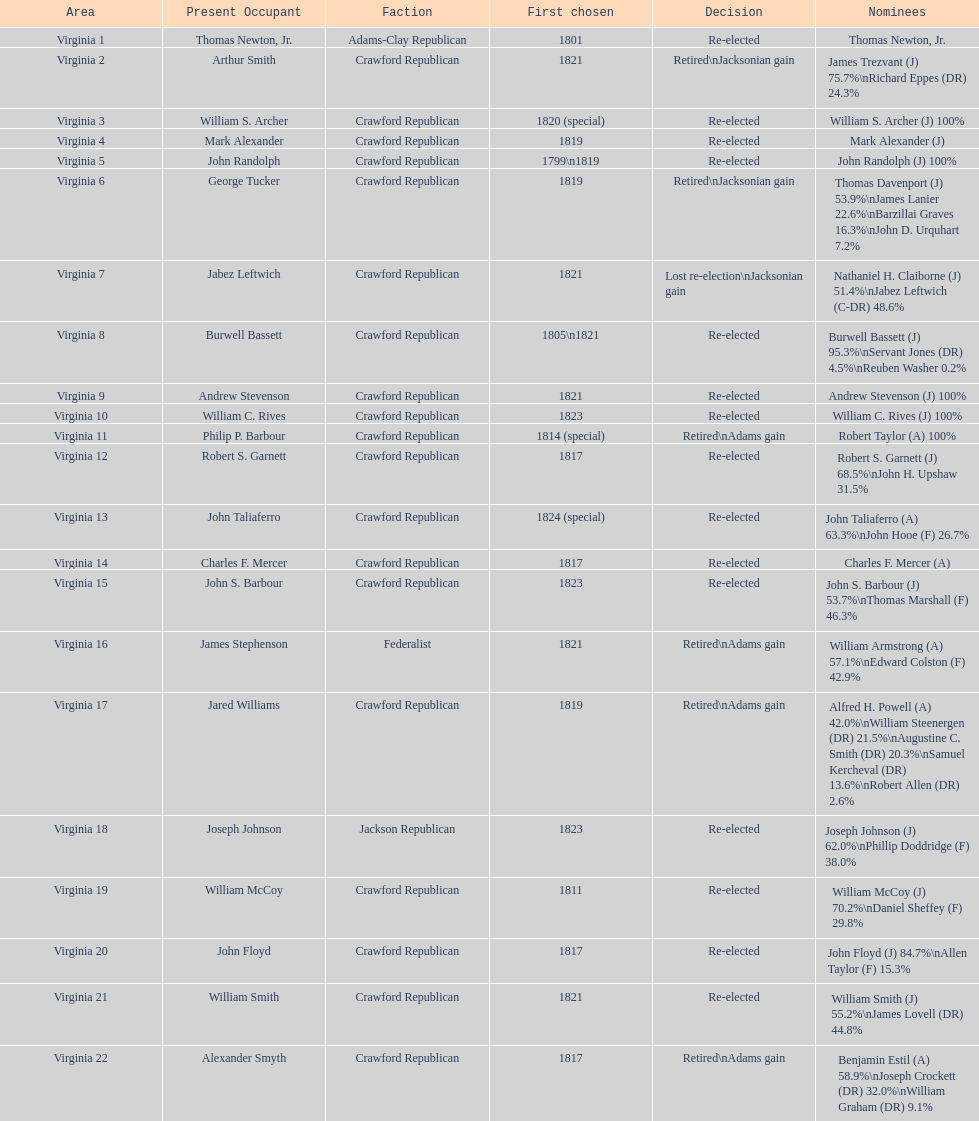Number of incumbents who retired or lost re-election 7. 